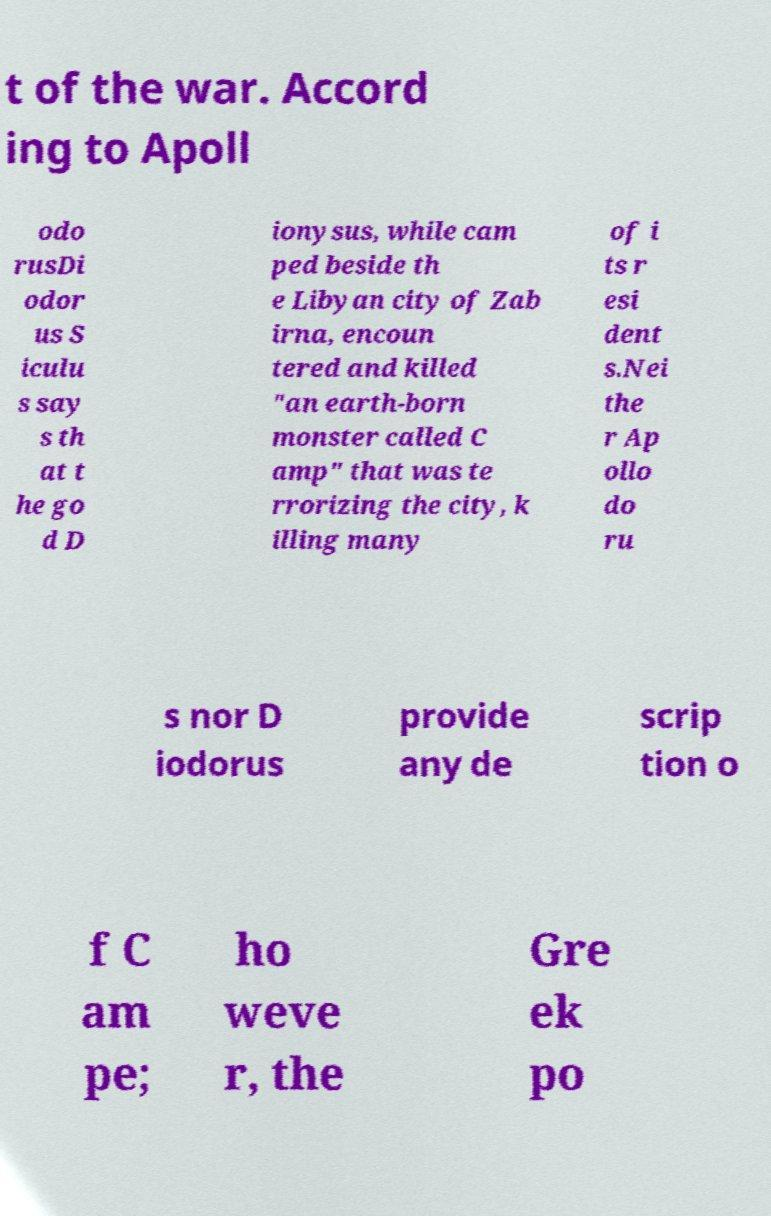Can you read and provide the text displayed in the image?This photo seems to have some interesting text. Can you extract and type it out for me? t of the war. Accord ing to Apoll odo rusDi odor us S iculu s say s th at t he go d D ionysus, while cam ped beside th e Libyan city of Zab irna, encoun tered and killed "an earth-born monster called C amp" that was te rrorizing the city, k illing many of i ts r esi dent s.Nei the r Ap ollo do ru s nor D iodorus provide any de scrip tion o f C am pe; ho weve r, the Gre ek po 